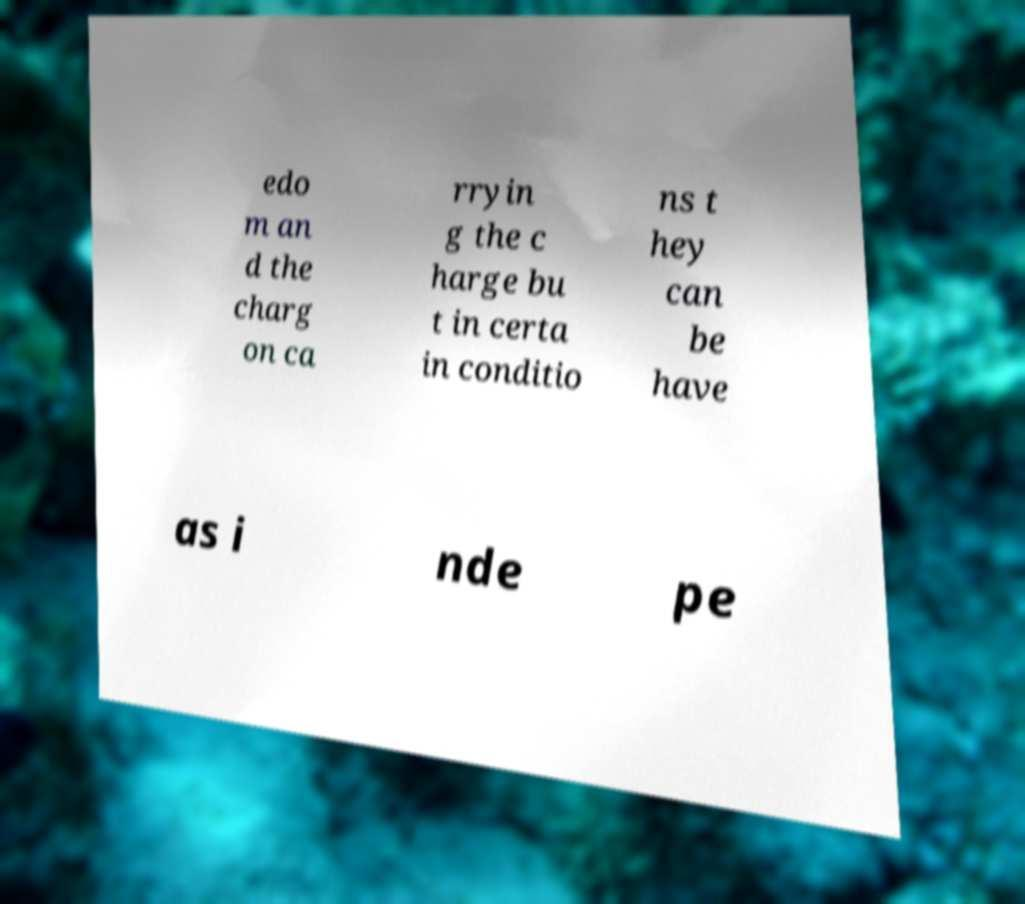Can you accurately transcribe the text from the provided image for me? edo m an d the charg on ca rryin g the c harge bu t in certa in conditio ns t hey can be have as i nde pe 